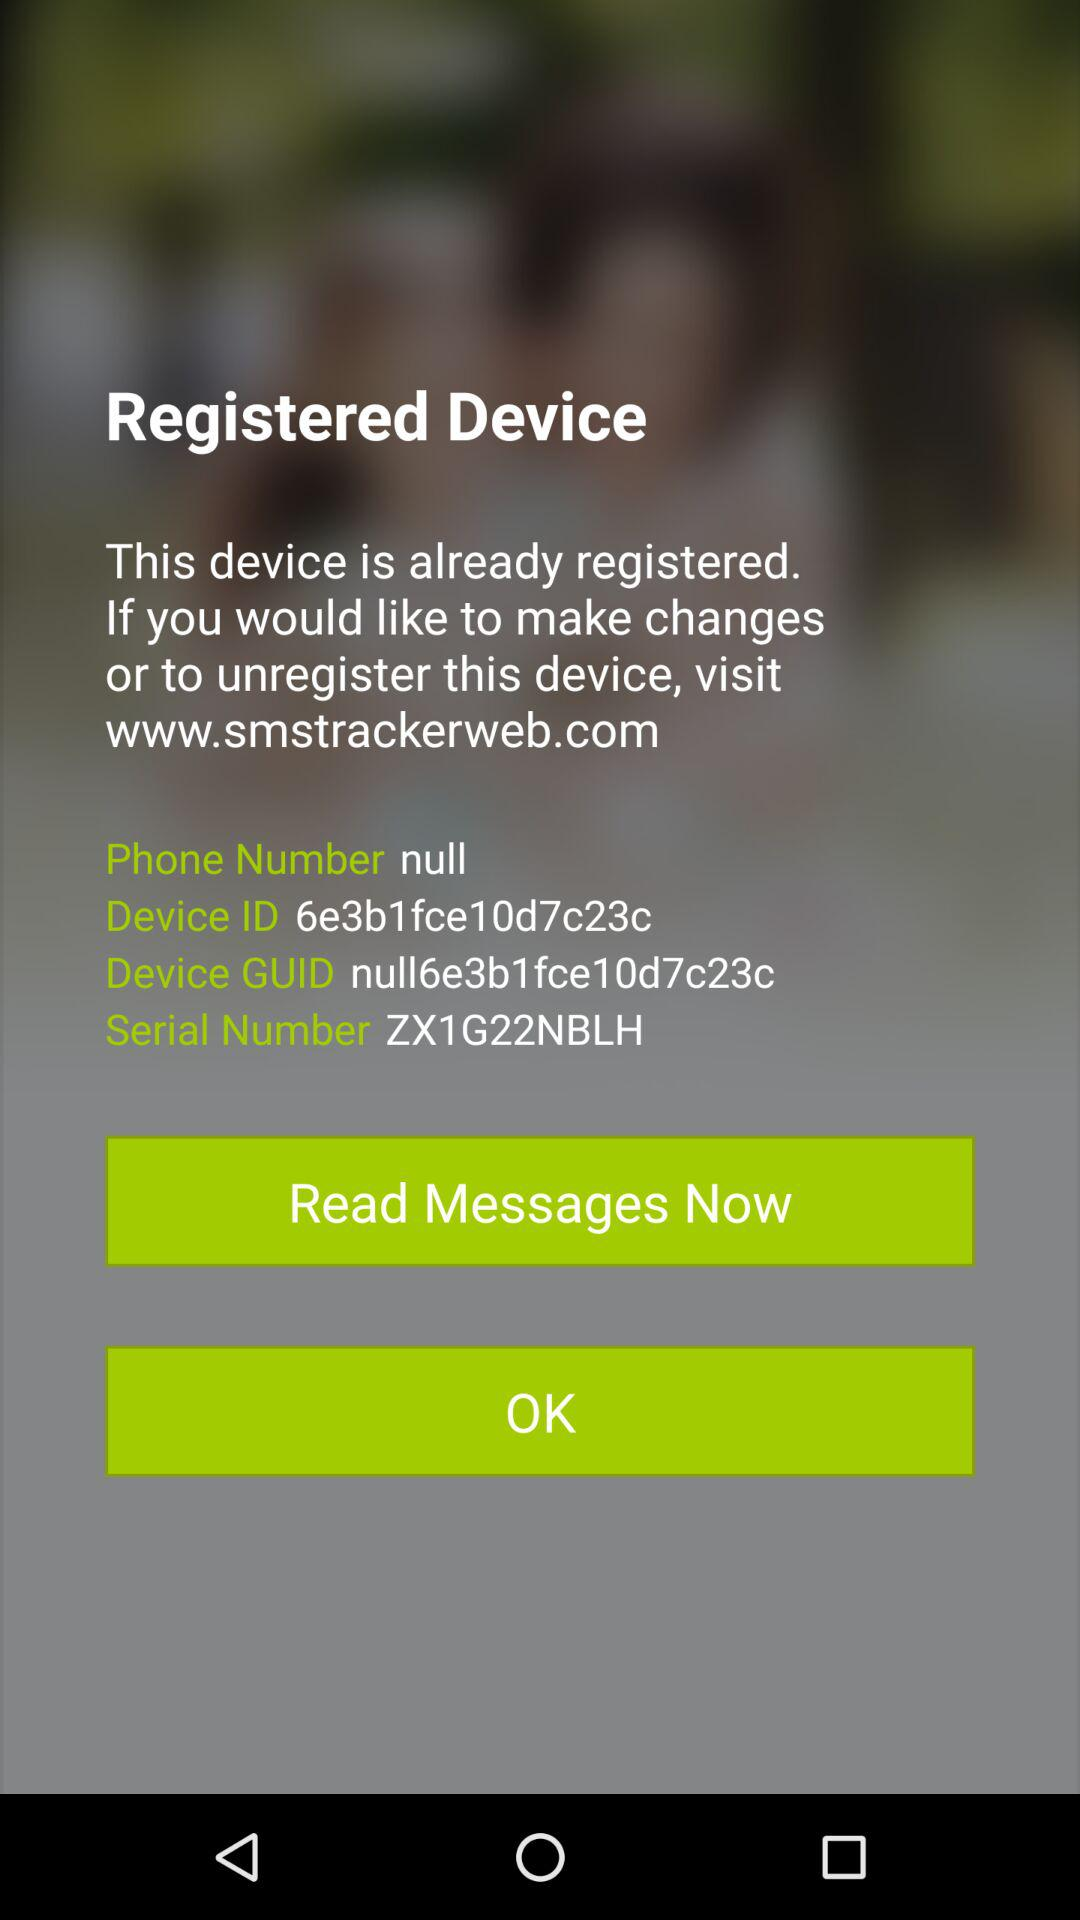What website do I have to visit if I want to make any changes or unregister the device? You have to visit www.smstrackerweb.com. 